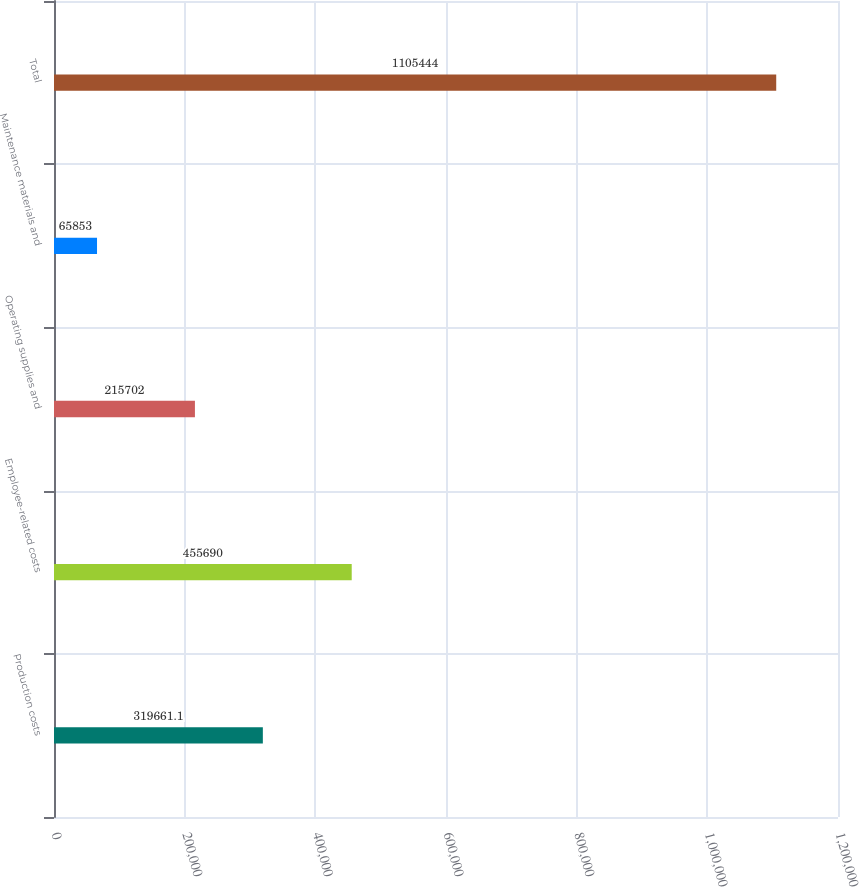<chart> <loc_0><loc_0><loc_500><loc_500><bar_chart><fcel>Production costs<fcel>Employee-related costs<fcel>Operating supplies and<fcel>Maintenance materials and<fcel>Total<nl><fcel>319661<fcel>455690<fcel>215702<fcel>65853<fcel>1.10544e+06<nl></chart> 